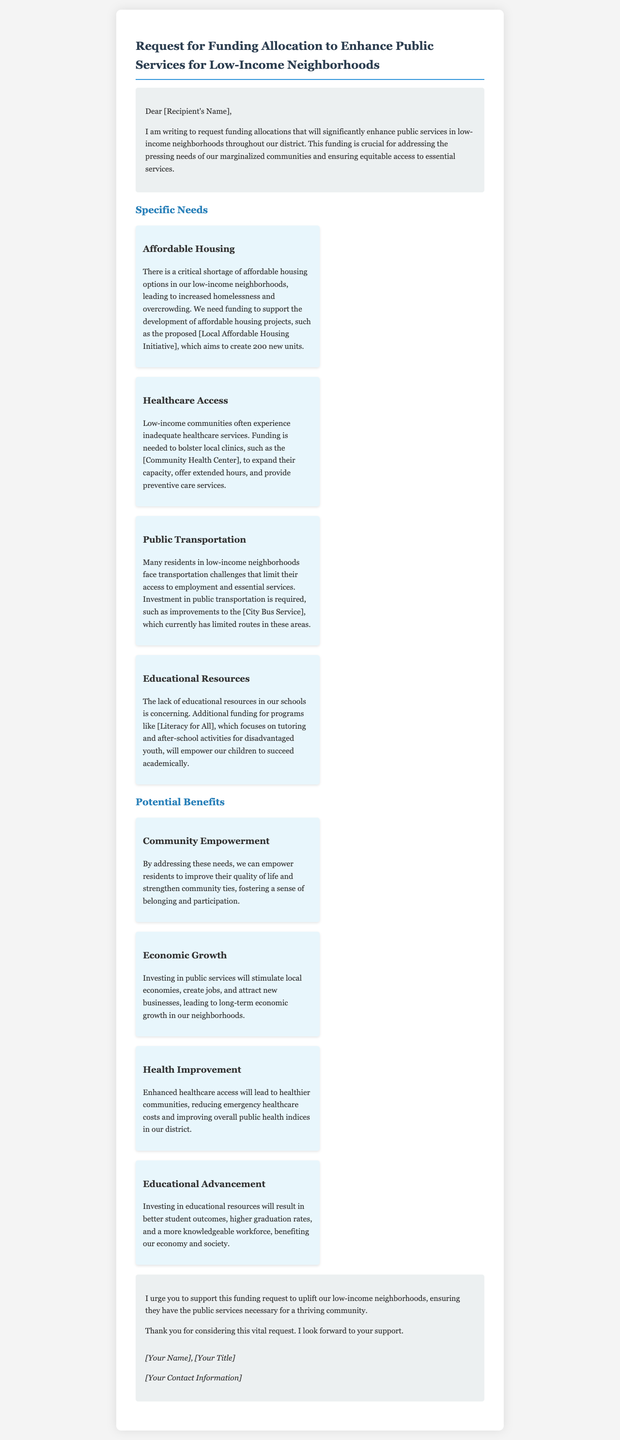What is the primary purpose of the letter? The letter's primary purpose is to request funding allocations to enhance public services in low-income neighborhoods.
Answer: request funding allocations How many new affordable housing units are proposed? The document states that the proposed initiative aims to create 200 new units.
Answer: 200 Which community health facility is mentioned? The letter refers to the [Community Health Center] for healthcare access improvements.
Answer: Community Health Center What transportation service is highlighted for improvement? The document highlights the [City Bus Service] as needing investment for better routes.
Answer: City Bus Service What specific program focuses on tutoring and after-school activities? The document mentions the program [Literacy for All] for tutoring and activities.
Answer: Literacy for All What is one potential benefit of healthcare access improvements? Enhanced healthcare access will lead to healthier communities as one of the benefits.
Answer: healthier communities What is a key aspect of community empowerment mentioned? The letter states that addressing needs can empower residents to improve their quality of life.
Answer: quality of life What is the conclusion urging the recipient to do? The conclusion urges the recipient to support the funding request for low-income neighborhoods.
Answer: support this funding request 